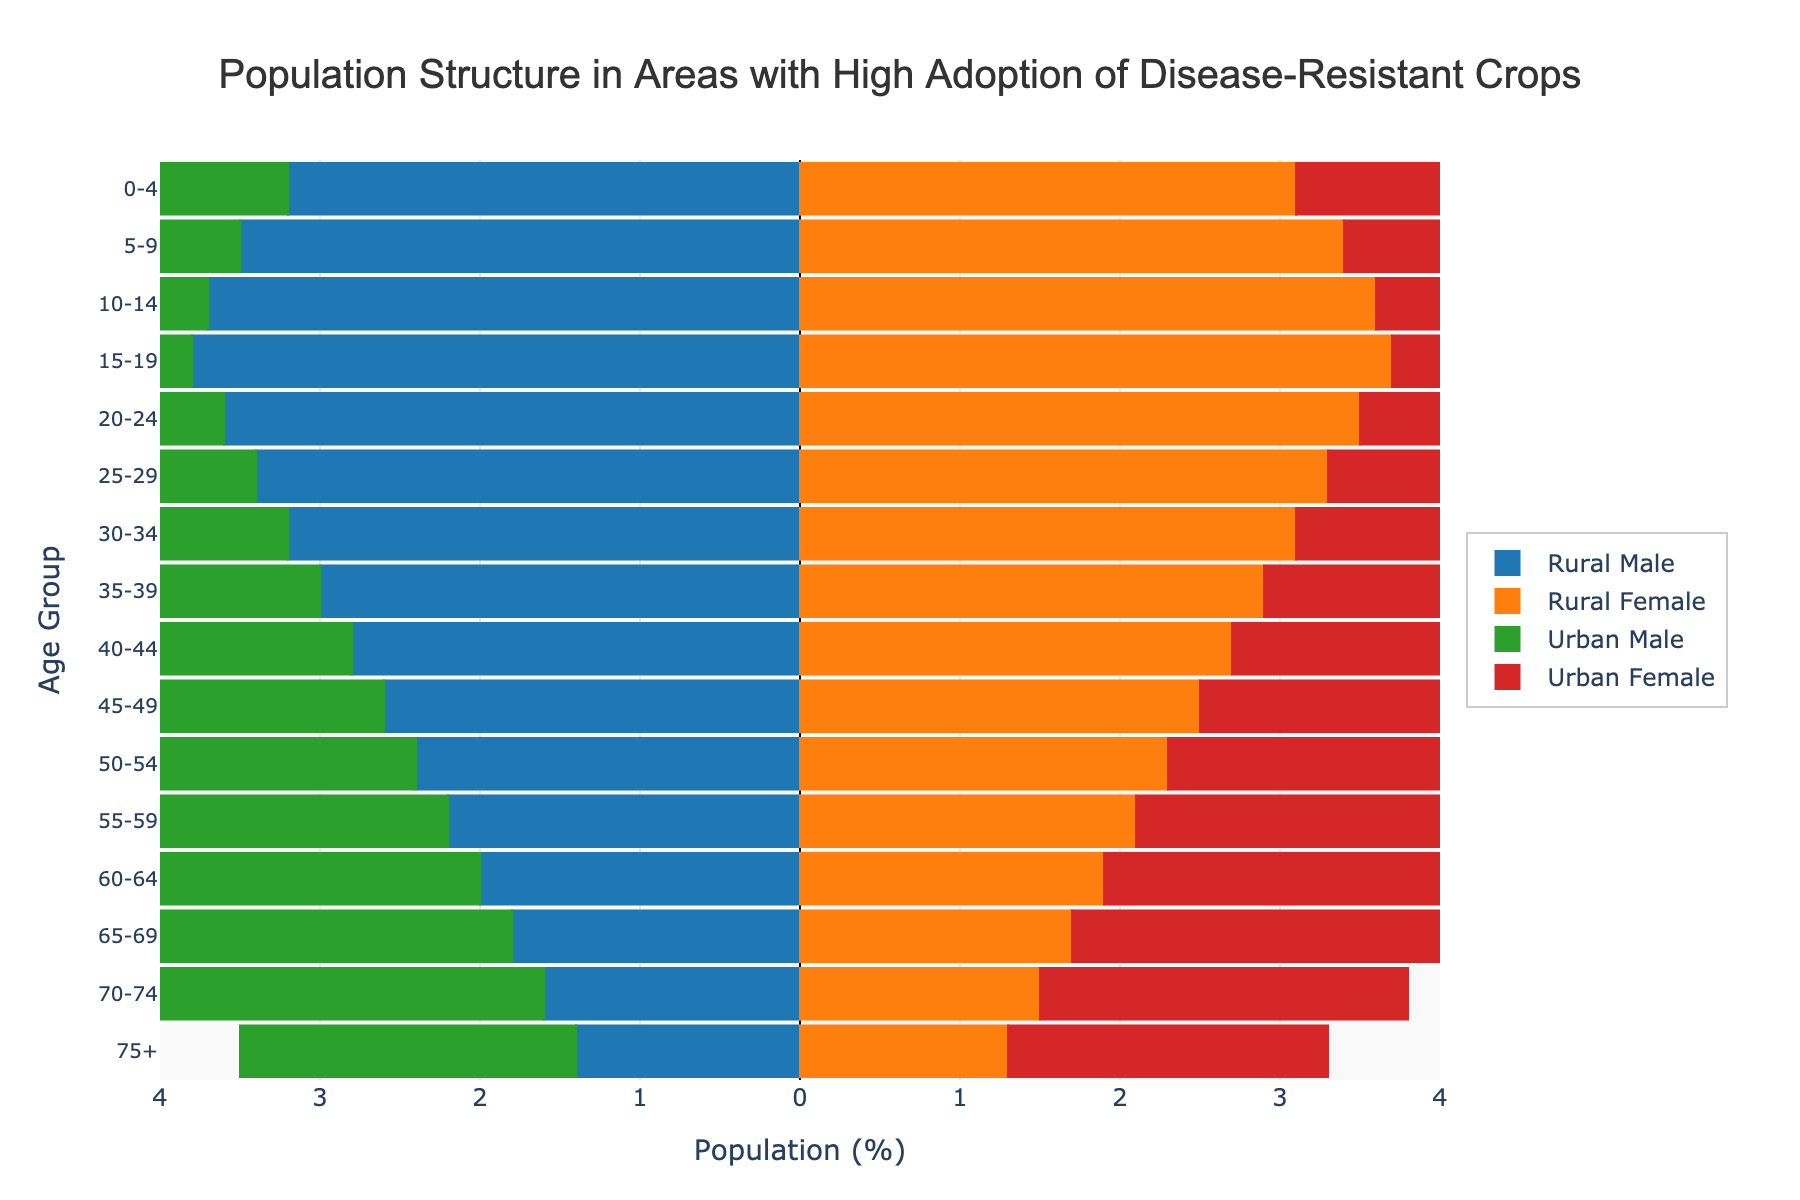What's the title of the figure? The title is prominently displayed at the top of the figure. It gives a clear indication of what the data represents.
Answer: Population Structure in Areas with High Adoption of Disease-Resistant Crops Which age group has the highest male population in rural areas? Look for the bar that extends the farthest to the left for the "Rural Male" category.
Answer: 15-19 Compare the population percentages of rural females and urban females in the 35-39 age group. Locate the bars corresponding to rural females and urban females for the 35-39 age group and compare their lengths.
Answer: Rural: 2.9%, Urban: 3.6% How does the population of urban males aged 45-49 compare to that of urban females in the same age group? Find the bars representing urban males and urban females for the 45-49 age group, and directly compare their lengths.
Answer: Urban females have a longer bar (3.6%) than urban males (3.7%) What is the population percentage difference between rural and urban males in the 60-64 age group? Subtract the population percentage of rural males from urban males in the 60-64 age group.
Answer: 3.0% - 2.0% = 1.0% What's the total population percentage (combined male and female) in urban areas for the 70-74 age group? Add the population percentages of urban males and urban females for the 70-74 age group.
Answer: 2.4% + 2.3% = 4.7% How does the population of urban females aged 15-19 compare with rural females of the same age group? Compare the lengths of the bars for urban females and rural females in the 15-19 age group.
Answer: Urban females have a shorter bar (3.0%) compared to rural females (3.7%) Which age group has the smallest population difference between rural and urban females? Calculate the absolute difference between the population percentages of rural and urban females for each age group and identify the smallest difference.
Answer: 0-4 (difference of 0.4%) In the age group 30-34, which gender and area has the highest population percentage? Identify the bar with the highest value among rural males, rural females, urban males, and urban females in the 30-34 age group.
Answer: Urban females (3.5%) Is there any age group where the population percentage is the same for rural and urban males? Check all age groups and compare the percentages for rural males and urban males.
Answer: No, there is no such age group 